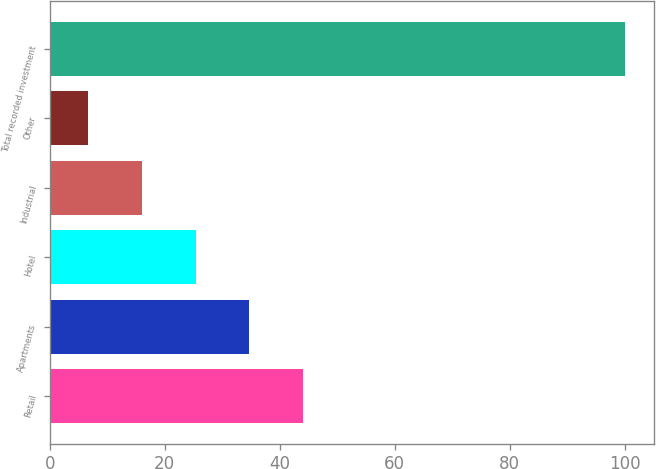<chart> <loc_0><loc_0><loc_500><loc_500><bar_chart><fcel>Retail<fcel>Apartments<fcel>Hotel<fcel>Industrial<fcel>Other<fcel>Total recorded investment<nl><fcel>44.02<fcel>34.69<fcel>25.36<fcel>16.03<fcel>6.7<fcel>100<nl></chart> 